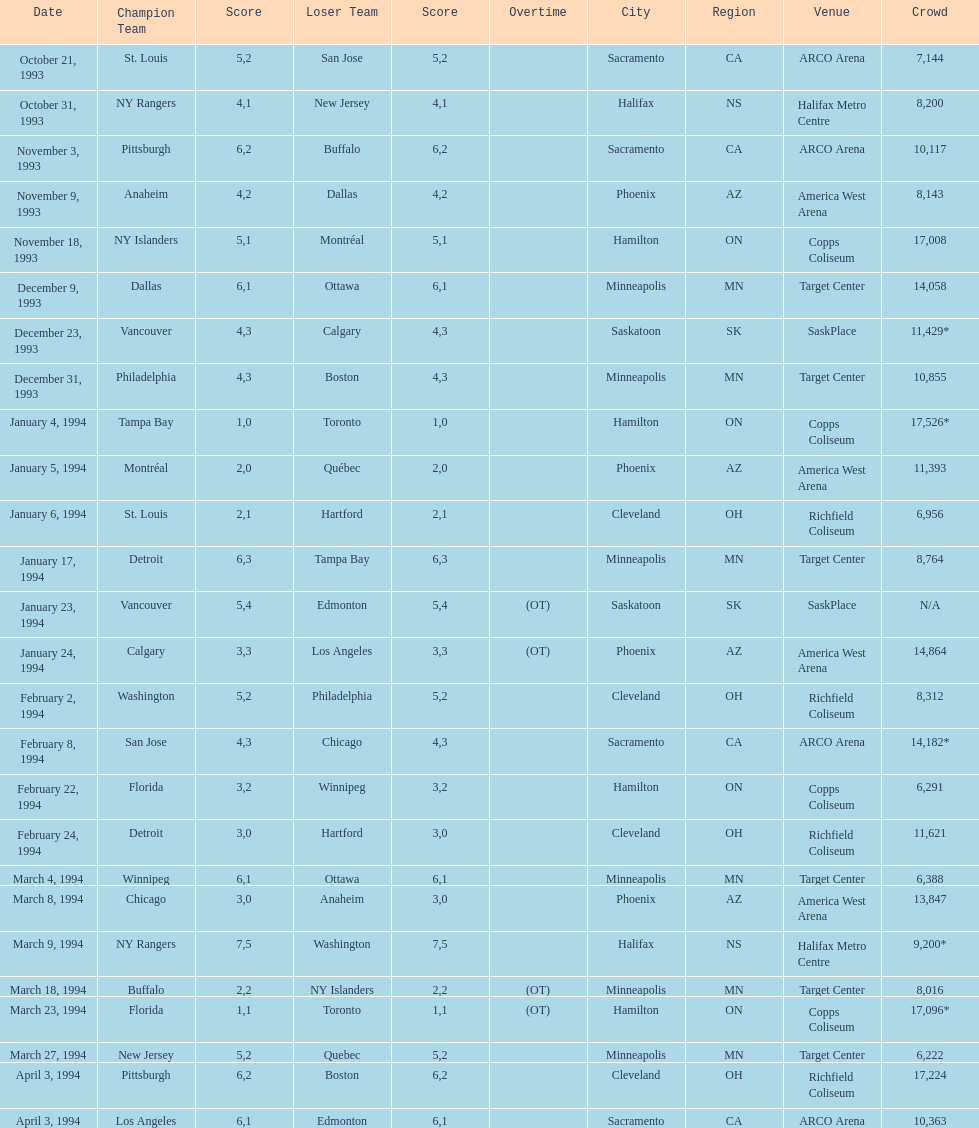Did dallas or ottawa win the december 9, 1993 game? Dallas. 